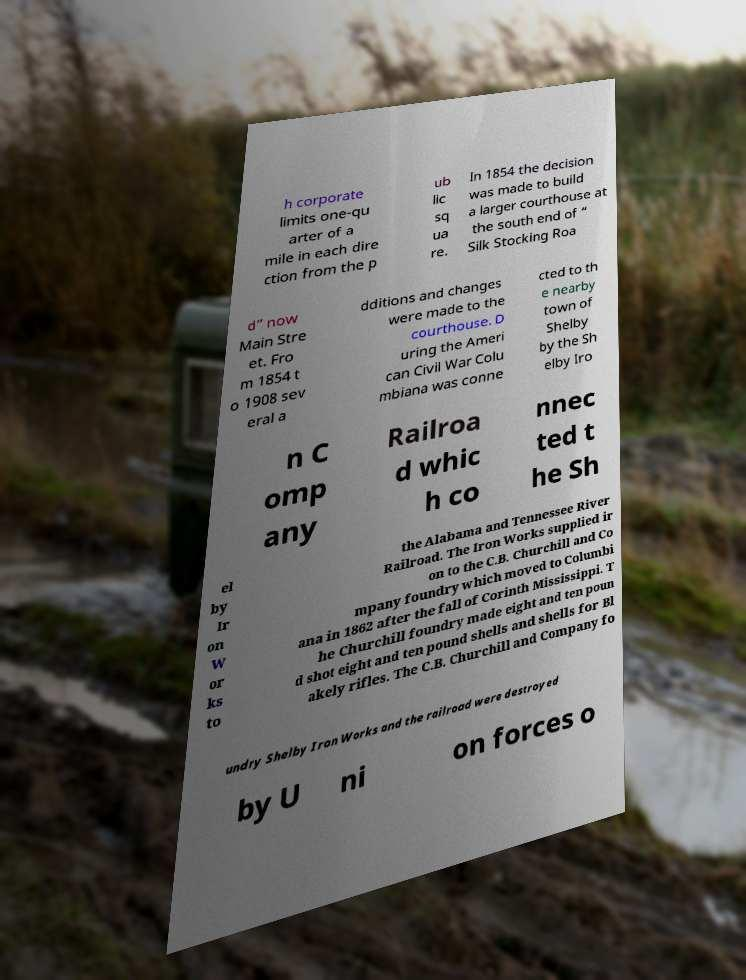What messages or text are displayed in this image? I need them in a readable, typed format. h corporate limits one-qu arter of a mile in each dire ction from the p ub lic sq ua re. In 1854 the decision was made to build a larger courthouse at the south end of “ Silk Stocking Roa d” now Main Stre et. Fro m 1854 t o 1908 sev eral a dditions and changes were made to the courthouse. D uring the Ameri can Civil War Colu mbiana was conne cted to th e nearby town of Shelby by the Sh elby Iro n C omp any Railroa d whic h co nnec ted t he Sh el by Ir on W or ks to the Alabama and Tennessee River Railroad. The Iron Works supplied ir on to the C.B. Churchill and Co mpany foundry which moved to Columbi ana in 1862 after the fall of Corinth Mississippi. T he Churchill foundry made eight and ten poun d shot eight and ten pound shells and shells for Bl akely rifles. The C.B. Churchill and Company fo undry Shelby Iron Works and the railroad were destroyed by U ni on forces o 